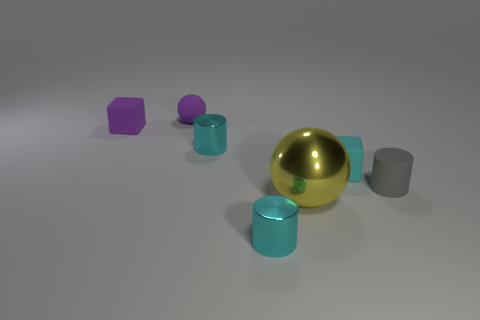How many tiny cubes have the same color as the large object? There are no tiny cubes sharing the same color as the large, gold-colored spherical object in the image. 